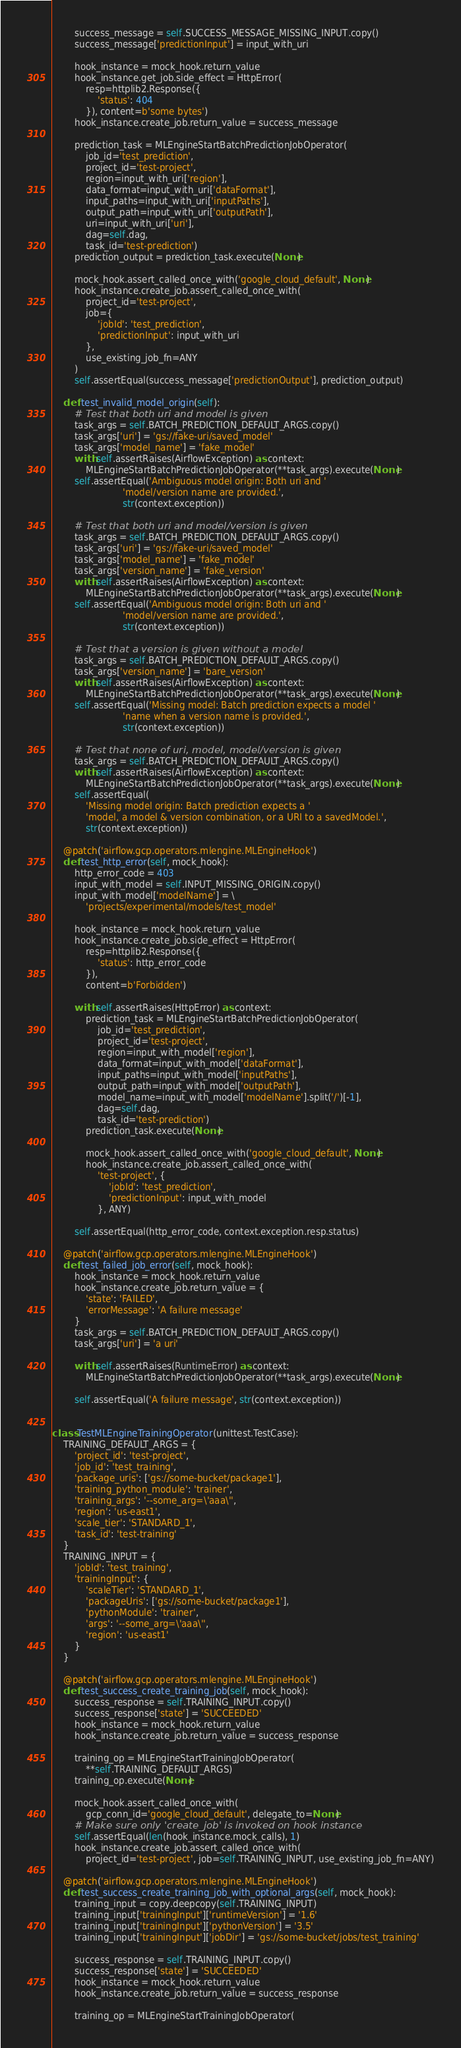Convert code to text. <code><loc_0><loc_0><loc_500><loc_500><_Python_>        success_message = self.SUCCESS_MESSAGE_MISSING_INPUT.copy()
        success_message['predictionInput'] = input_with_uri

        hook_instance = mock_hook.return_value
        hook_instance.get_job.side_effect = HttpError(
            resp=httplib2.Response({
                'status': 404
            }), content=b'some bytes')
        hook_instance.create_job.return_value = success_message

        prediction_task = MLEngineStartBatchPredictionJobOperator(
            job_id='test_prediction',
            project_id='test-project',
            region=input_with_uri['region'],
            data_format=input_with_uri['dataFormat'],
            input_paths=input_with_uri['inputPaths'],
            output_path=input_with_uri['outputPath'],
            uri=input_with_uri['uri'],
            dag=self.dag,
            task_id='test-prediction')
        prediction_output = prediction_task.execute(None)

        mock_hook.assert_called_once_with('google_cloud_default', None)
        hook_instance.create_job.assert_called_once_with(
            project_id='test-project',
            job={
                'jobId': 'test_prediction',
                'predictionInput': input_with_uri
            },
            use_existing_job_fn=ANY
        )
        self.assertEqual(success_message['predictionOutput'], prediction_output)

    def test_invalid_model_origin(self):
        # Test that both uri and model is given
        task_args = self.BATCH_PREDICTION_DEFAULT_ARGS.copy()
        task_args['uri'] = 'gs://fake-uri/saved_model'
        task_args['model_name'] = 'fake_model'
        with self.assertRaises(AirflowException) as context:
            MLEngineStartBatchPredictionJobOperator(**task_args).execute(None)
        self.assertEqual('Ambiguous model origin: Both uri and '
                         'model/version name are provided.',
                         str(context.exception))

        # Test that both uri and model/version is given
        task_args = self.BATCH_PREDICTION_DEFAULT_ARGS.copy()
        task_args['uri'] = 'gs://fake-uri/saved_model'
        task_args['model_name'] = 'fake_model'
        task_args['version_name'] = 'fake_version'
        with self.assertRaises(AirflowException) as context:
            MLEngineStartBatchPredictionJobOperator(**task_args).execute(None)
        self.assertEqual('Ambiguous model origin: Both uri and '
                         'model/version name are provided.',
                         str(context.exception))

        # Test that a version is given without a model
        task_args = self.BATCH_PREDICTION_DEFAULT_ARGS.copy()
        task_args['version_name'] = 'bare_version'
        with self.assertRaises(AirflowException) as context:
            MLEngineStartBatchPredictionJobOperator(**task_args).execute(None)
        self.assertEqual('Missing model: Batch prediction expects a model '
                         'name when a version name is provided.',
                         str(context.exception))

        # Test that none of uri, model, model/version is given
        task_args = self.BATCH_PREDICTION_DEFAULT_ARGS.copy()
        with self.assertRaises(AirflowException) as context:
            MLEngineStartBatchPredictionJobOperator(**task_args).execute(None)
        self.assertEqual(
            'Missing model origin: Batch prediction expects a '
            'model, a model & version combination, or a URI to a savedModel.',
            str(context.exception))

    @patch('airflow.gcp.operators.mlengine.MLEngineHook')
    def test_http_error(self, mock_hook):
        http_error_code = 403
        input_with_model = self.INPUT_MISSING_ORIGIN.copy()
        input_with_model['modelName'] = \
            'projects/experimental/models/test_model'

        hook_instance = mock_hook.return_value
        hook_instance.create_job.side_effect = HttpError(
            resp=httplib2.Response({
                'status': http_error_code
            }),
            content=b'Forbidden')

        with self.assertRaises(HttpError) as context:
            prediction_task = MLEngineStartBatchPredictionJobOperator(
                job_id='test_prediction',
                project_id='test-project',
                region=input_with_model['region'],
                data_format=input_with_model['dataFormat'],
                input_paths=input_with_model['inputPaths'],
                output_path=input_with_model['outputPath'],
                model_name=input_with_model['modelName'].split('/')[-1],
                dag=self.dag,
                task_id='test-prediction')
            prediction_task.execute(None)

            mock_hook.assert_called_once_with('google_cloud_default', None)
            hook_instance.create_job.assert_called_once_with(
                'test-project', {
                    'jobId': 'test_prediction',
                    'predictionInput': input_with_model
                }, ANY)

        self.assertEqual(http_error_code, context.exception.resp.status)

    @patch('airflow.gcp.operators.mlengine.MLEngineHook')
    def test_failed_job_error(self, mock_hook):
        hook_instance = mock_hook.return_value
        hook_instance.create_job.return_value = {
            'state': 'FAILED',
            'errorMessage': 'A failure message'
        }
        task_args = self.BATCH_PREDICTION_DEFAULT_ARGS.copy()
        task_args['uri'] = 'a uri'

        with self.assertRaises(RuntimeError) as context:
            MLEngineStartBatchPredictionJobOperator(**task_args).execute(None)

        self.assertEqual('A failure message', str(context.exception))


class TestMLEngineTrainingOperator(unittest.TestCase):
    TRAINING_DEFAULT_ARGS = {
        'project_id': 'test-project',
        'job_id': 'test_training',
        'package_uris': ['gs://some-bucket/package1'],
        'training_python_module': 'trainer',
        'training_args': '--some_arg=\'aaa\'',
        'region': 'us-east1',
        'scale_tier': 'STANDARD_1',
        'task_id': 'test-training'
    }
    TRAINING_INPUT = {
        'jobId': 'test_training',
        'trainingInput': {
            'scaleTier': 'STANDARD_1',
            'packageUris': ['gs://some-bucket/package1'],
            'pythonModule': 'trainer',
            'args': '--some_arg=\'aaa\'',
            'region': 'us-east1'
        }
    }

    @patch('airflow.gcp.operators.mlengine.MLEngineHook')
    def test_success_create_training_job(self, mock_hook):
        success_response = self.TRAINING_INPUT.copy()
        success_response['state'] = 'SUCCEEDED'
        hook_instance = mock_hook.return_value
        hook_instance.create_job.return_value = success_response

        training_op = MLEngineStartTrainingJobOperator(
            **self.TRAINING_DEFAULT_ARGS)
        training_op.execute(None)

        mock_hook.assert_called_once_with(
            gcp_conn_id='google_cloud_default', delegate_to=None)
        # Make sure only 'create_job' is invoked on hook instance
        self.assertEqual(len(hook_instance.mock_calls), 1)
        hook_instance.create_job.assert_called_once_with(
            project_id='test-project', job=self.TRAINING_INPUT, use_existing_job_fn=ANY)

    @patch('airflow.gcp.operators.mlengine.MLEngineHook')
    def test_success_create_training_job_with_optional_args(self, mock_hook):
        training_input = copy.deepcopy(self.TRAINING_INPUT)
        training_input['trainingInput']['runtimeVersion'] = '1.6'
        training_input['trainingInput']['pythonVersion'] = '3.5'
        training_input['trainingInput']['jobDir'] = 'gs://some-bucket/jobs/test_training'

        success_response = self.TRAINING_INPUT.copy()
        success_response['state'] = 'SUCCEEDED'
        hook_instance = mock_hook.return_value
        hook_instance.create_job.return_value = success_response

        training_op = MLEngineStartTrainingJobOperator(</code> 